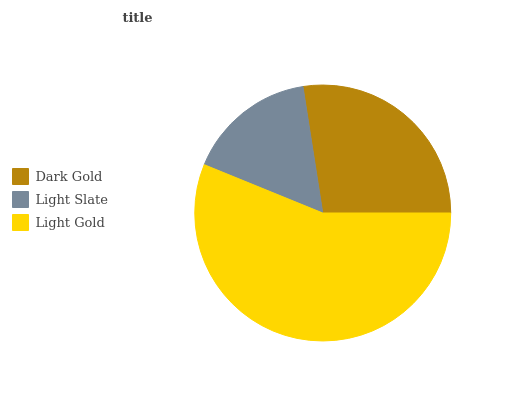Is Light Slate the minimum?
Answer yes or no. Yes. Is Light Gold the maximum?
Answer yes or no. Yes. Is Light Gold the minimum?
Answer yes or no. No. Is Light Slate the maximum?
Answer yes or no. No. Is Light Gold greater than Light Slate?
Answer yes or no. Yes. Is Light Slate less than Light Gold?
Answer yes or no. Yes. Is Light Slate greater than Light Gold?
Answer yes or no. No. Is Light Gold less than Light Slate?
Answer yes or no. No. Is Dark Gold the high median?
Answer yes or no. Yes. Is Dark Gold the low median?
Answer yes or no. Yes. Is Light Slate the high median?
Answer yes or no. No. Is Light Gold the low median?
Answer yes or no. No. 